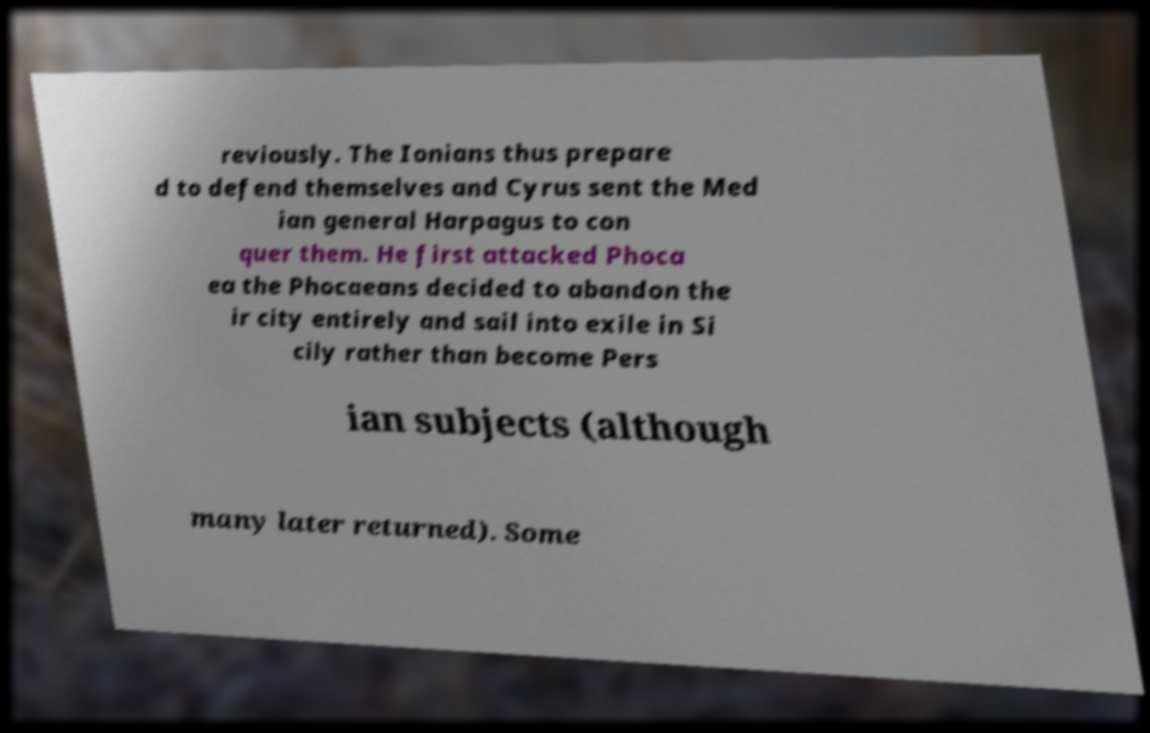What messages or text are displayed in this image? I need them in a readable, typed format. reviously. The Ionians thus prepare d to defend themselves and Cyrus sent the Med ian general Harpagus to con quer them. He first attacked Phoca ea the Phocaeans decided to abandon the ir city entirely and sail into exile in Si cily rather than become Pers ian subjects (although many later returned). Some 